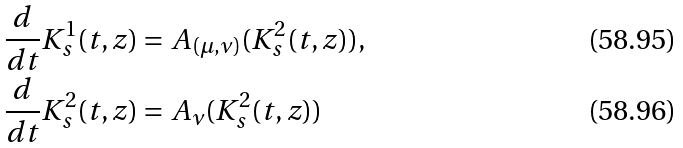<formula> <loc_0><loc_0><loc_500><loc_500>& \frac { d } { d t } K _ { s } ^ { 1 } ( t , z ) = A _ { ( \mu , \nu ) } ( K ^ { 2 } _ { s } ( t , z ) ) , \\ & \frac { d } { d t } K _ { s } ^ { 2 } ( t , z ) = A _ { \nu } ( K _ { s } ^ { 2 } ( t , z ) )</formula> 